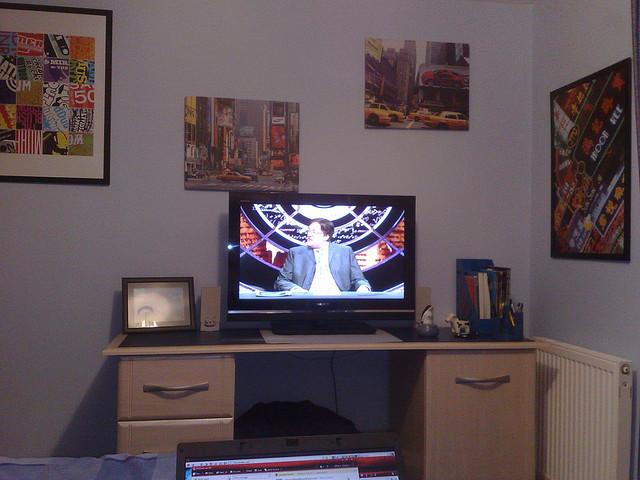What kind of artwork is framed on the left side of the screen on the wall? collage 